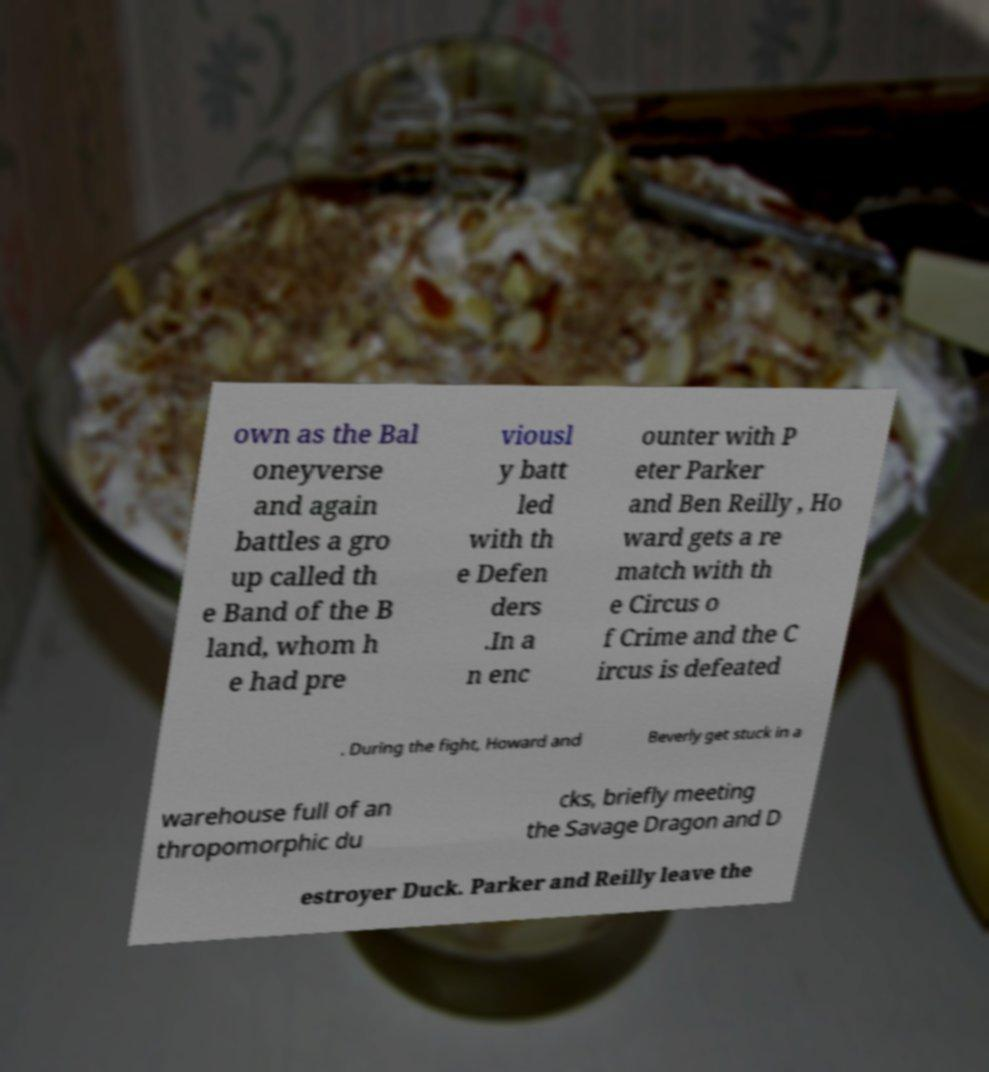Please identify and transcribe the text found in this image. own as the Bal oneyverse and again battles a gro up called th e Band of the B land, whom h e had pre viousl y batt led with th e Defen ders .In a n enc ounter with P eter Parker and Ben Reilly , Ho ward gets a re match with th e Circus o f Crime and the C ircus is defeated . During the fight, Howard and Beverly get stuck in a warehouse full of an thropomorphic du cks, briefly meeting the Savage Dragon and D estroyer Duck. Parker and Reilly leave the 